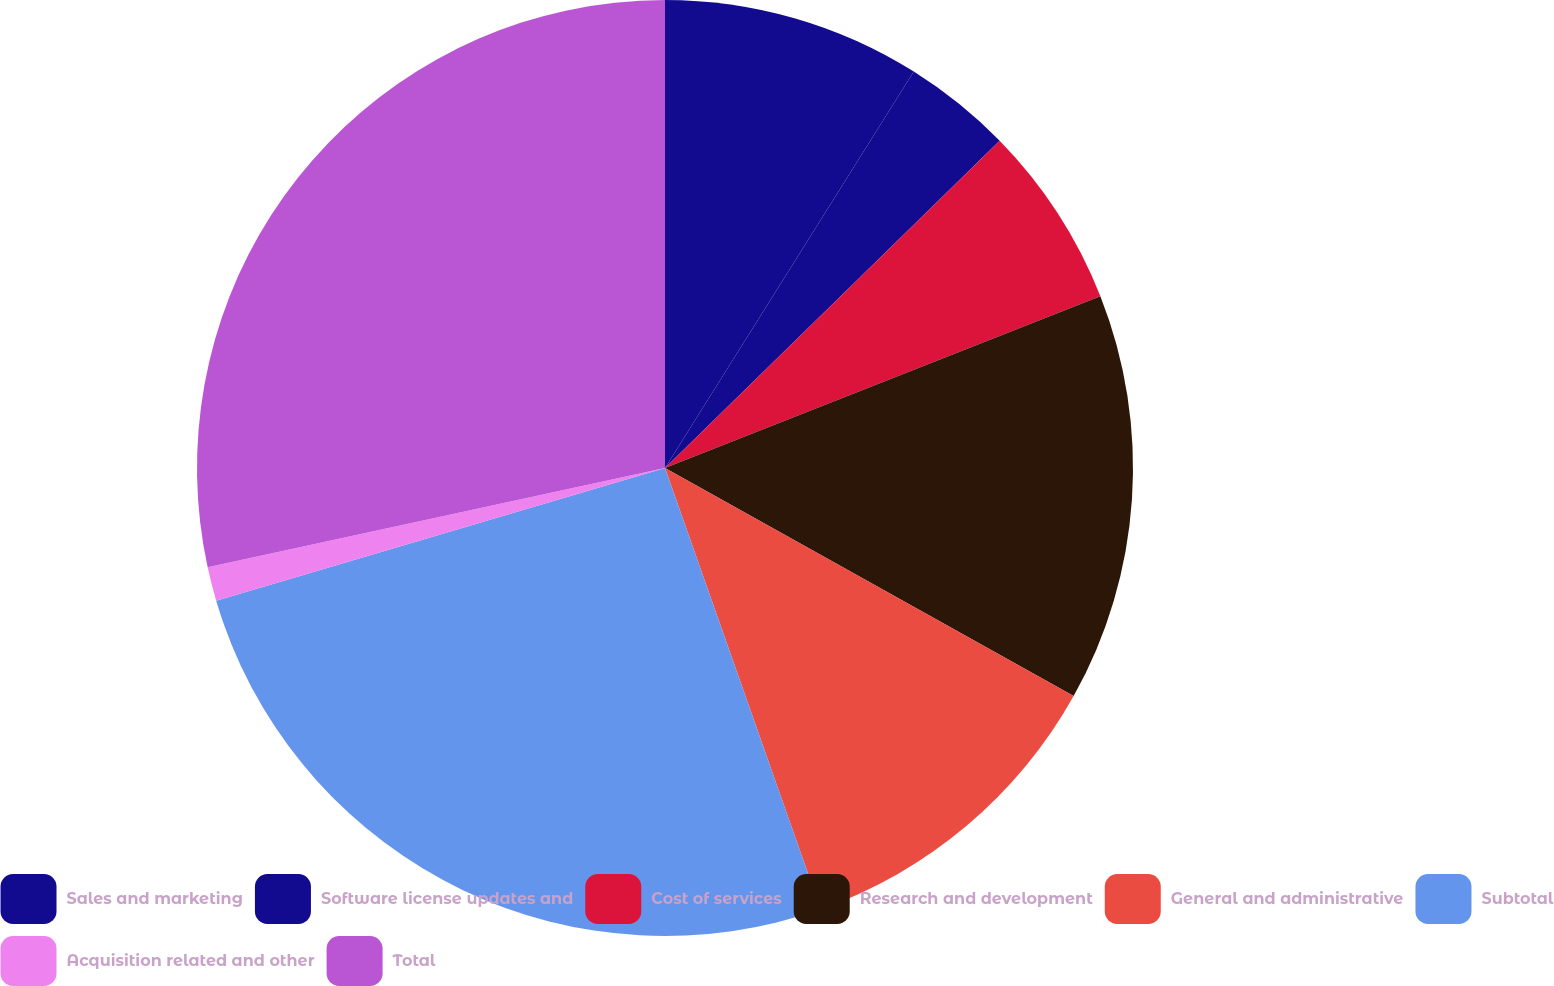Convert chart to OTSL. <chart><loc_0><loc_0><loc_500><loc_500><pie_chart><fcel>Sales and marketing<fcel>Software license updates and<fcel>Cost of services<fcel>Research and development<fcel>General and administrative<fcel>Subtotal<fcel>Acquisition related and other<fcel>Total<nl><fcel>8.92%<fcel>3.76%<fcel>6.34%<fcel>14.08%<fcel>11.5%<fcel>25.82%<fcel>1.17%<fcel>28.4%<nl></chart> 